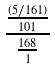Convert formula to latex. <formula><loc_0><loc_0><loc_500><loc_500>\frac { \frac { ( 5 / 1 6 1 ) } { 1 0 1 } } { \frac { 1 6 8 } { 1 } }</formula> 